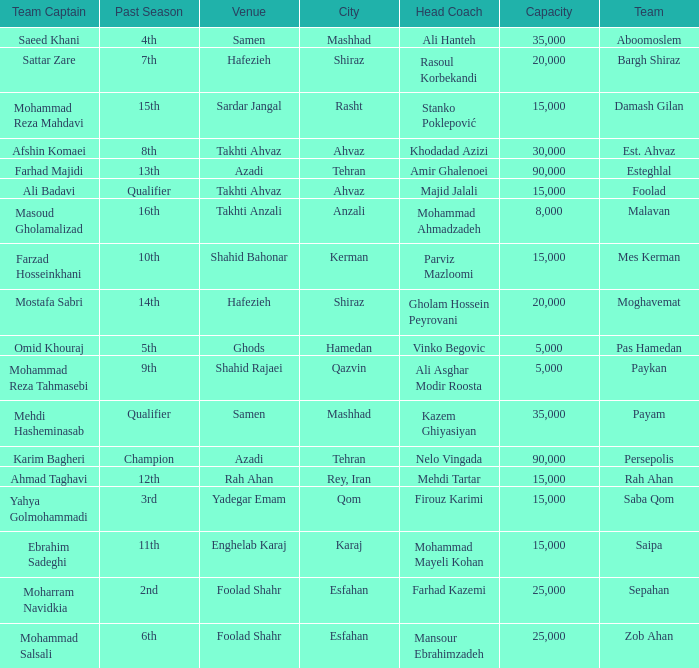What is the Capacity of the Venue of Head Coach Ali Asghar Modir Roosta? 5000.0. 